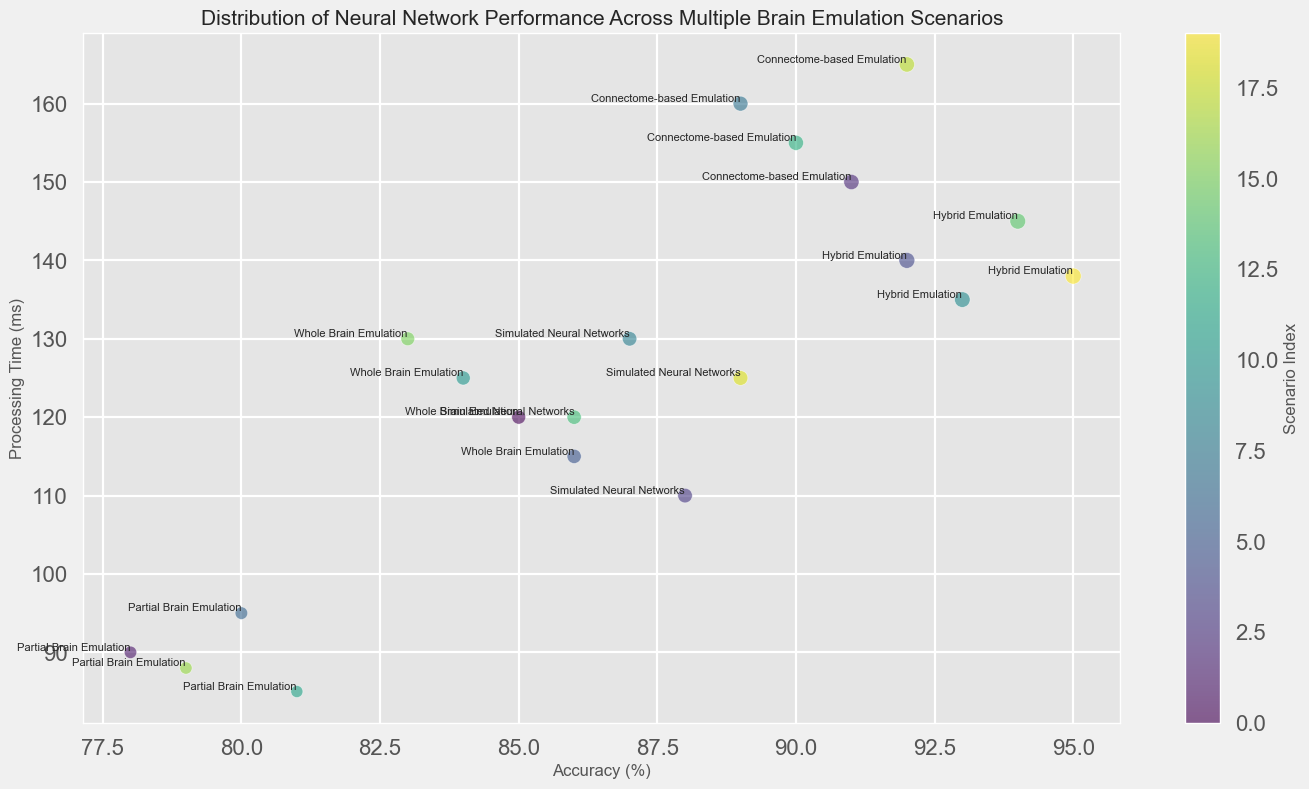what is the highest accuracy achieved, and by which emulation method? First, look at the accuracy axis and find the highest value (95%). Then, check the text annotation near this bubble to identify the emulation method.
Answer: 95%, Hybrid Emulation Which scenario has the shortest processing time with an accuracy greater than 85%? Locate bubbles with accuracy greater than 85% and find the one with the lowest processing time. The lowest processing time with accuracy more than 85% is 85 ms.
Answer: Scenario 12 How many scenarios have an accuracy below 80%? Count the number of bubbles with accuracy below 80% (there are 3 bubbles for scenarios 2, 7, and 17).
Answer: 3 Compare the processing times of Whole Brain Emulation in scenarios 1, 6, 11, and 16. Which has the longest processing time and which has the shortest? Inspect the bubbles' processing times that correspond to these scenarios: 120 ms (Scenario 1), 115 ms (Scenario 6), 125 ms (Scenario 11), and 130 ms (Scenario 16). The longest processing time is 130 ms and the shortest is 115 ms.
Answer: Longest: Scenario 16, Shortest: Scenario 6 In which scenario did the Hybrid Emulation method achieve the highest accuracy, and what was its processing time? Find the bubbles annotated with "Hybrid Emulation" and identify the one with the highest accuracy (95%). The corresponding processing time is 138 ms.
Answer: Scenario 20, 138 ms What's the average accuracy of Connectome-based Emulation across all scenarios? Sum the accuracies of Connectome-based Emulation for all scenarios (91 + 89 + 90 + 92 = 362), then divide by the number of such scenarios (4). The average accuracy is 362/4 = 90.5%.
Answer: 90.5% Which emulation method has the most consistent processing time, based on the range of its values across scenarios? Calculate the range by finding the difference between the maximum and minimum processing times for each method: Whole Brain Emulation (130-115 = 15), Partial Brain Emulation (95-85 = 10), Connectome-based Emulation (165-150 = 15), Simulated Neural Networks (130-110 = 20), and Hybrid Emulation (145-135 = 10). Partial Brain Emulation and Hybrid Emulation both have the smallest range (10 ms).
Answer: Partial Brain Emulation & Hybrid Emulation (tie) Among Simulated Neural Networks scenarios, which one has the largest bubble size, and what does it indicate? Compare the bubble sizes for scenarios with Simulated Neural Networks. Scenario 19 has the largest bubble size (112). This indicates that it has the highest significance according to the specified metric.
Answer: Scenario 19, indicates highest significance Which scenario has the lowest accuracy while still achieving a processing time under 100 ms? Identify the bubbles with a processing time under 100 ms, and among these, locate the one with the lowest accuracy (Scenario 12 with 81% accuracy).
Answer: Scenario 12 What is the most frequent accuracy value across all scenarios, and how often does it appear? Count the occurrences of each accuracy value. The most frequent value is 89%, which appears in scenarios 8 and 19.
Answer: 89%, 2 times 